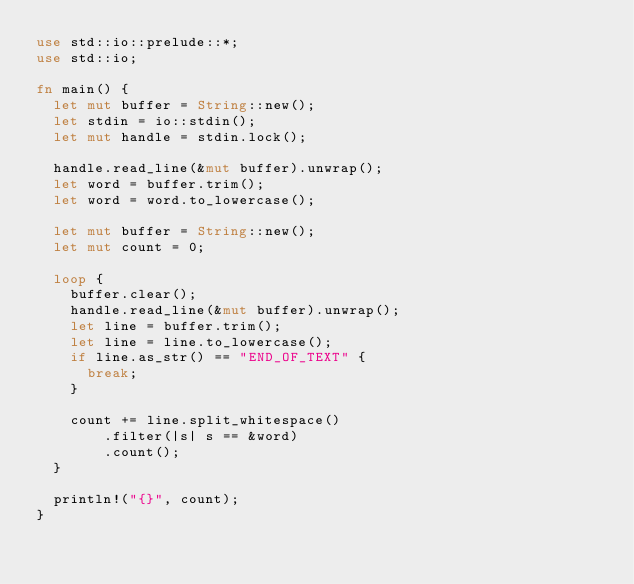Convert code to text. <code><loc_0><loc_0><loc_500><loc_500><_Rust_>use std::io::prelude::*;
use std::io;

fn main() {
  let mut buffer = String::new();
  let stdin = io::stdin();
  let mut handle = stdin.lock();

  handle.read_line(&mut buffer).unwrap();
  let word = buffer.trim();
  let word = word.to_lowercase();

  let mut buffer = String::new();
  let mut count = 0;
  
  loop {
    buffer.clear();
    handle.read_line(&mut buffer).unwrap();
    let line = buffer.trim();
    let line = line.to_lowercase();
    if line.as_str() == "END_OF_TEXT" {
      break;
    }
    
    count += line.split_whitespace()
        .filter(|s| s == &word)
        .count();
  }

  println!("{}", count);
}</code> 